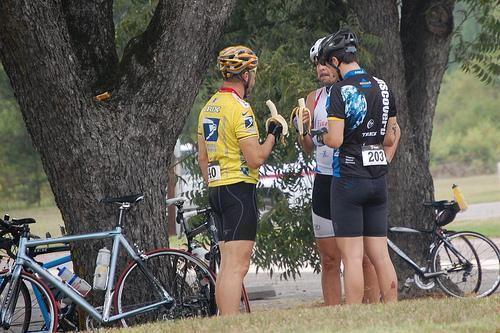How many men are there?
Give a very brief answer. 3. How many bikers are eating a banana?
Give a very brief answer. 2. How many people in this picture have bananas?
Give a very brief answer. 2. How many people are eating bananas?
Give a very brief answer. 2. 